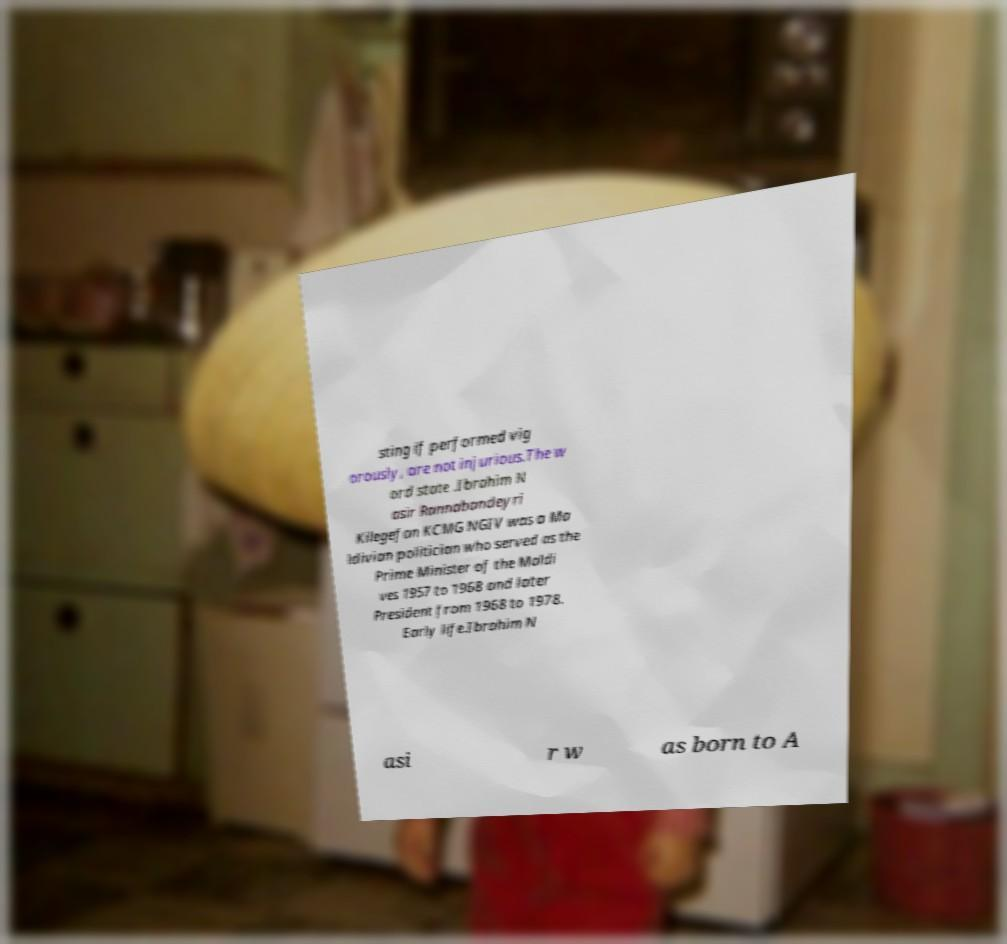For documentation purposes, I need the text within this image transcribed. Could you provide that? sting if performed vig orously, are not injurious.The w ord state .Ibrahim N asir Rannabandeyri Kilegefan KCMG NGIV was a Ma ldivian politician who served as the Prime Minister of the Maldi ves 1957 to 1968 and later President from 1968 to 1978. Early life.Ibrahim N asi r w as born to A 